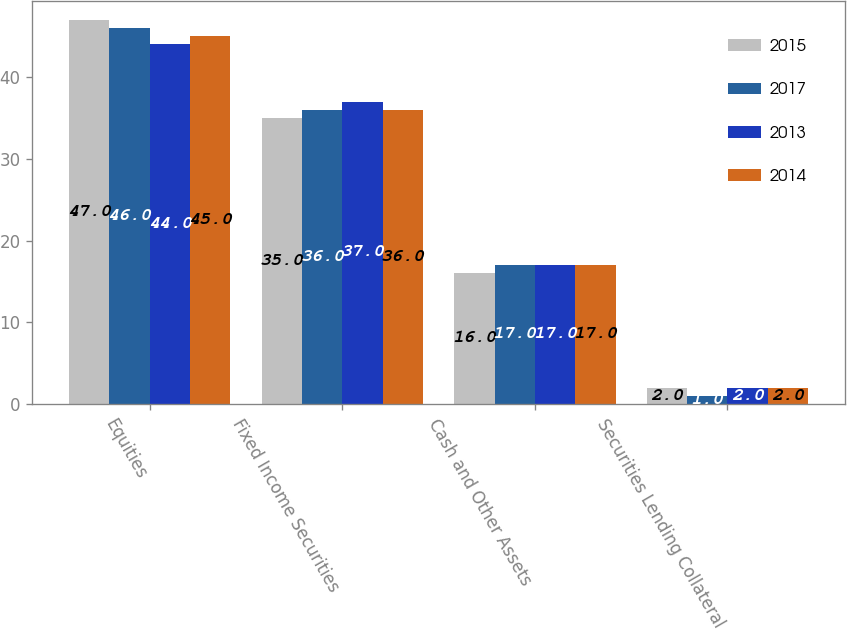<chart> <loc_0><loc_0><loc_500><loc_500><stacked_bar_chart><ecel><fcel>Equities<fcel>Fixed Income Securities<fcel>Cash and Other Assets<fcel>Securities Lending Collateral<nl><fcel>2015<fcel>47<fcel>35<fcel>16<fcel>2<nl><fcel>2017<fcel>46<fcel>36<fcel>17<fcel>1<nl><fcel>2013<fcel>44<fcel>37<fcel>17<fcel>2<nl><fcel>2014<fcel>45<fcel>36<fcel>17<fcel>2<nl></chart> 